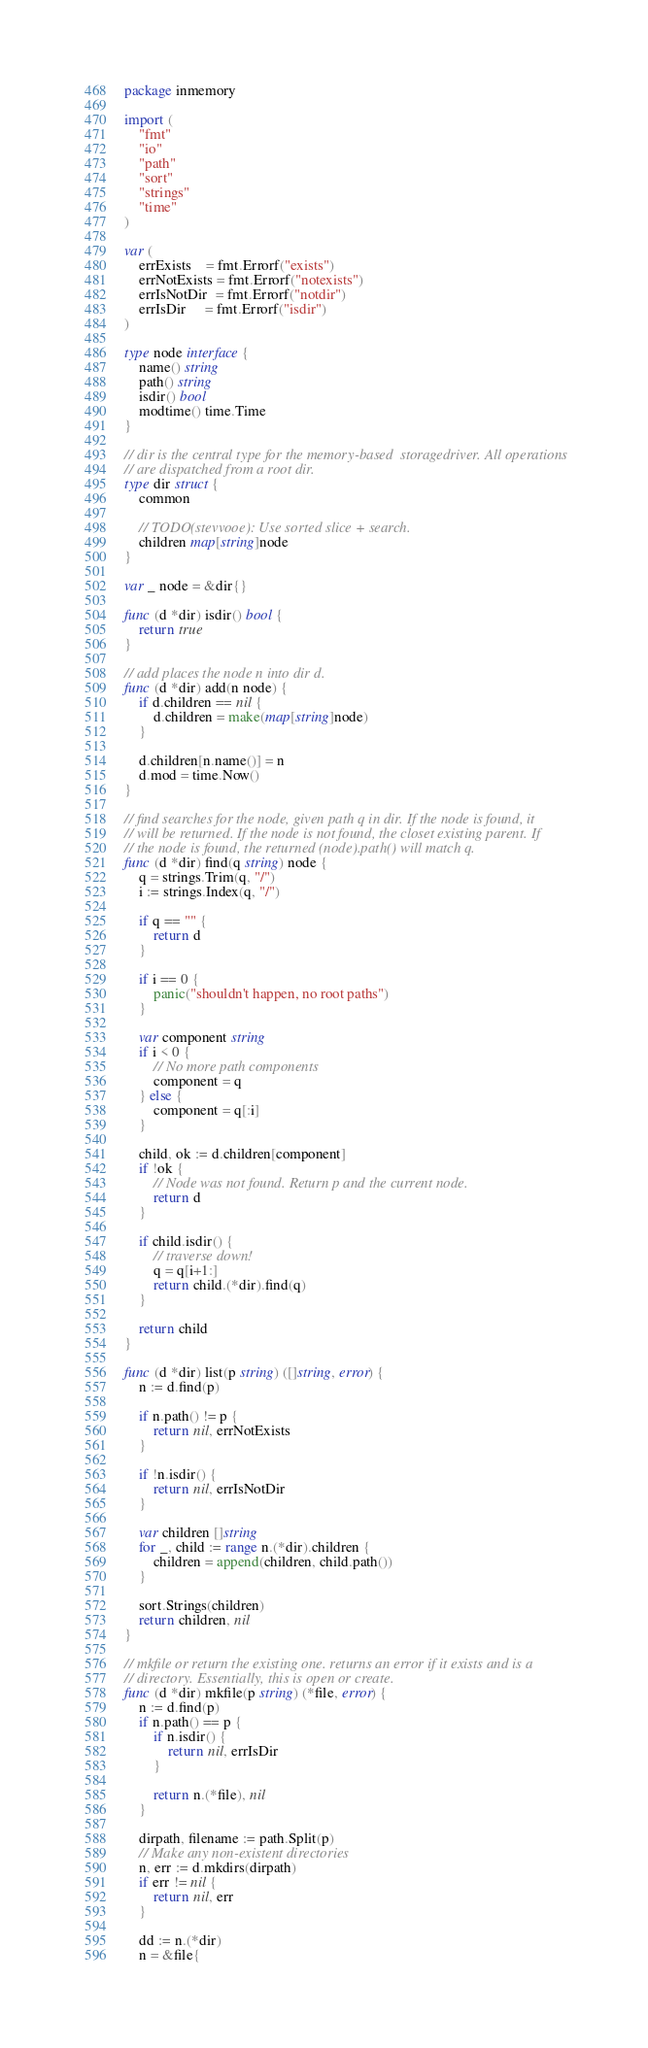Convert code to text. <code><loc_0><loc_0><loc_500><loc_500><_Go_>package inmemory

import (
	"fmt"
	"io"
	"path"
	"sort"
	"strings"
	"time"
)

var (
	errExists    = fmt.Errorf("exists")
	errNotExists = fmt.Errorf("notexists")
	errIsNotDir  = fmt.Errorf("notdir")
	errIsDir     = fmt.Errorf("isdir")
)

type node interface {
	name() string
	path() string
	isdir() bool
	modtime() time.Time
}

// dir is the central type for the memory-based  storagedriver. All operations
// are dispatched from a root dir.
type dir struct {
	common

	// TODO(stevvooe): Use sorted slice + search.
	children map[string]node
}

var _ node = &dir{}

func (d *dir) isdir() bool {
	return true
}

// add places the node n into dir d.
func (d *dir) add(n node) {
	if d.children == nil {
		d.children = make(map[string]node)
	}

	d.children[n.name()] = n
	d.mod = time.Now()
}

// find searches for the node, given path q in dir. If the node is found, it
// will be returned. If the node is not found, the closet existing parent. If
// the node is found, the returned (node).path() will match q.
func (d *dir) find(q string) node {
	q = strings.Trim(q, "/")
	i := strings.Index(q, "/")

	if q == "" {
		return d
	}

	if i == 0 {
		panic("shouldn't happen, no root paths")
	}

	var component string
	if i < 0 {
		// No more path components
		component = q
	} else {
		component = q[:i]
	}

	child, ok := d.children[component]
	if !ok {
		// Node was not found. Return p and the current node.
		return d
	}

	if child.isdir() {
		// traverse down!
		q = q[i+1:]
		return child.(*dir).find(q)
	}

	return child
}

func (d *dir) list(p string) ([]string, error) {
	n := d.find(p)

	if n.path() != p {
		return nil, errNotExists
	}

	if !n.isdir() {
		return nil, errIsNotDir
	}

	var children []string
	for _, child := range n.(*dir).children {
		children = append(children, child.path())
	}

	sort.Strings(children)
	return children, nil
}

// mkfile or return the existing one. returns an error if it exists and is a
// directory. Essentially, this is open or create.
func (d *dir) mkfile(p string) (*file, error) {
	n := d.find(p)
	if n.path() == p {
		if n.isdir() {
			return nil, errIsDir
		}

		return n.(*file), nil
	}

	dirpath, filename := path.Split(p)
	// Make any non-existent directories
	n, err := d.mkdirs(dirpath)
	if err != nil {
		return nil, err
	}

	dd := n.(*dir)
	n = &file{</code> 